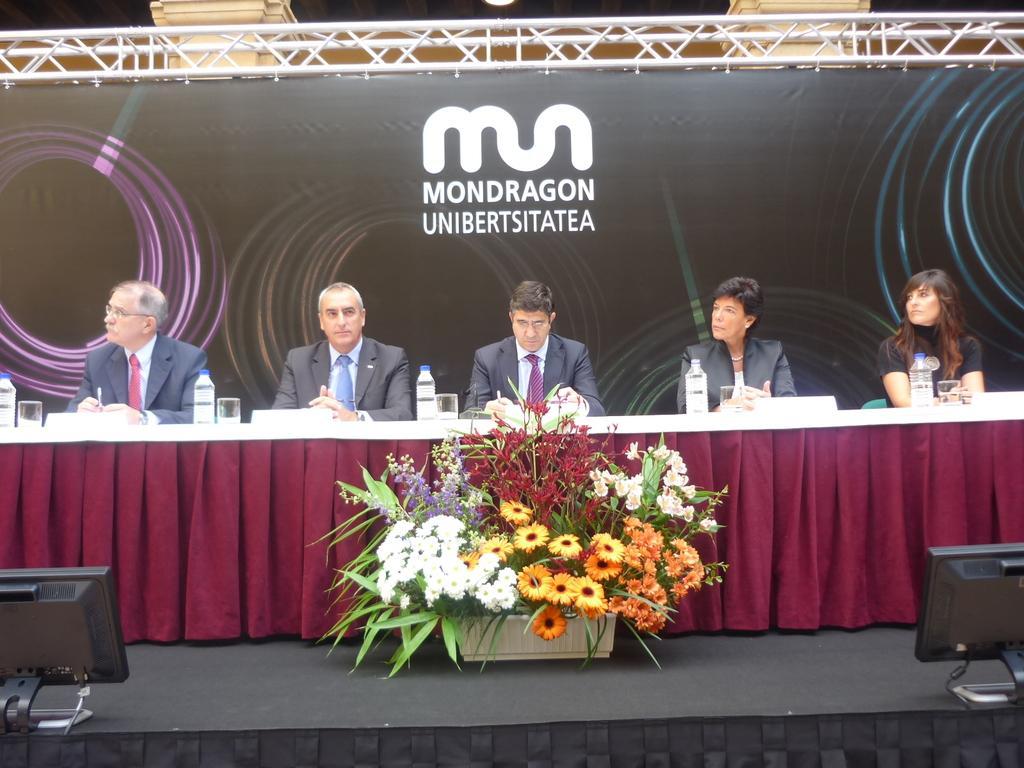Could you give a brief overview of what you see in this image? In this image there are some persons sitting as we can see in the middle of this image and there is a table is covered with a cloth in the middle of this image. There are some flowers in a pot in the bottom of this image. There is a wall in the background. There is some text written on the top of this image. There is an object in the bottom left corner of this image and in the bottom right corner of this image as well. 